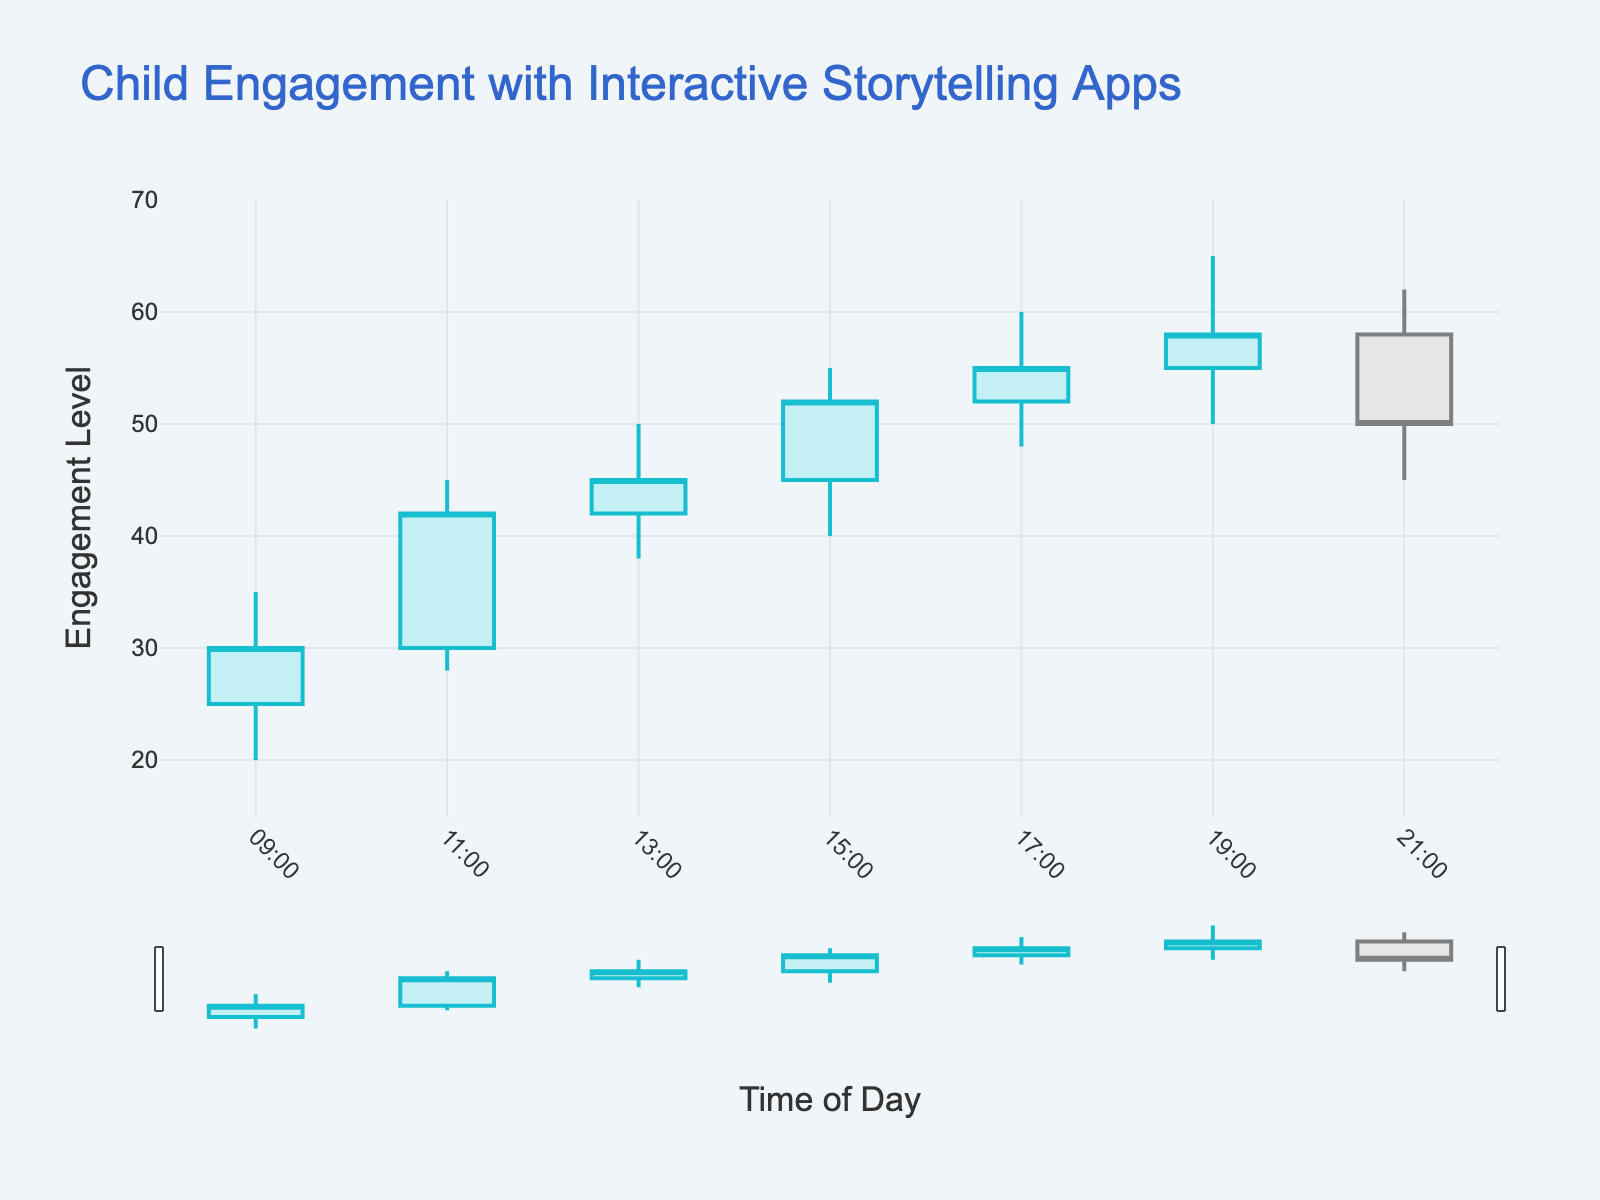What is the title of the figure? The figure's title is displayed at the top of the chart.
Answer: Child Engagement with Interactive Storytelling Apps What is the time interval of the data points? By inspecting the x-axis, we can see that the increments occur every two hours.
Answer: Every two hours At what time was the highest engagement level recorded? The highest recorded engagement level can be found in the 'High' column. It is visible at the 19:00 time slot.
Answer: 19:00 What are the open and close engagement levels at 09:00? Referring to the 09:00 time entry, the open value is 25 and the close value is 30.
Answer: Open: 25; Close: 30 During which time period did the engagement level increase the most from open to close? By comparing the difference between the open and close values for each time period, the maximum increase is from 45 to 52 at the 15:00 slot.
Answer: 15:00 At what times did the closing engagement level fall below 50? Analyzing the 'Close' column, the closing engagement levels below 50 are at 09:00 and 21:00.
Answer: 09:00, 21:00 What is the overall trend of the engagement levels throughout the day? Observing the general movement of the highs, lows, opens, and closes, it can be seen that engagement levels generally increase until 19:00 and slightly decrease afterward.
Answer: Increase, then slight decrease How does the engagement level at 21:00 compare to that at 11:00? Referring to the 'Close' values: at 11:00 it was 42 and at 21:00 it was 50, indicating a higher engagement level at 21:00.
Answer: Higher at 21:00 What is the range of engagement levels at 17:00? The range is determined by subtracting the 'Low' value from the 'High' value for 17:00, which is 60 - 48 = 12.
Answer: 12 Which time slot had the widest range of engagement levels? The time slot with the widest range can be identified by finding the maximum (High - Low) difference, which is 65 - 50 = 15 at 19:00.
Answer: 19:00 